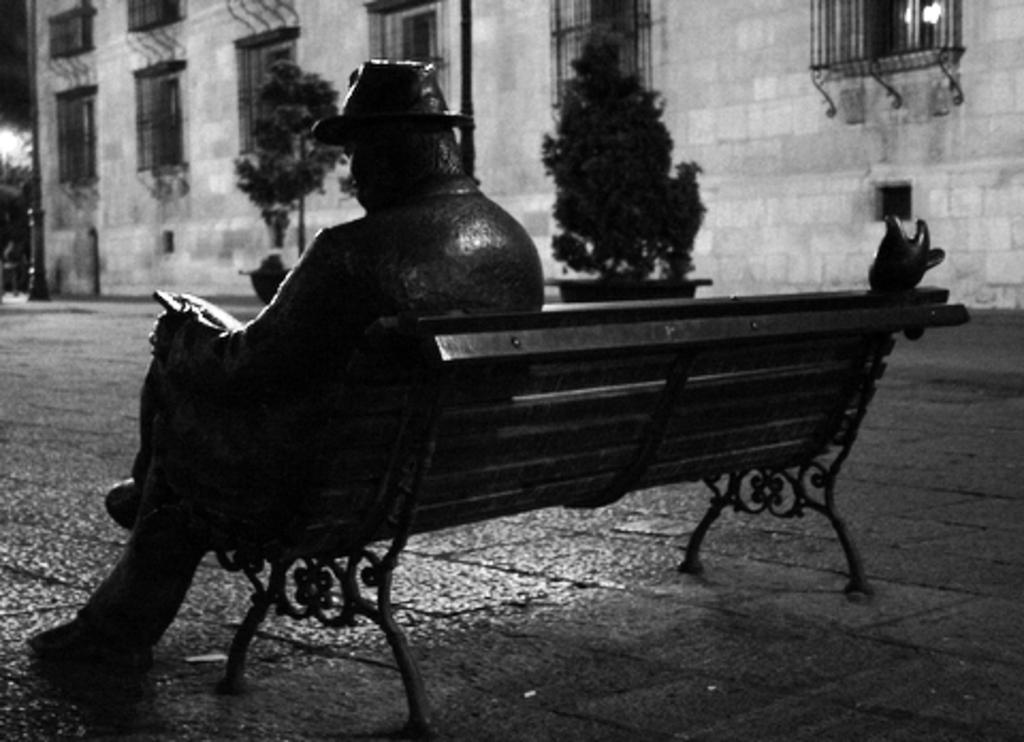What is the main subject of the image? There is a statue of a person sitting on a bench in the image. What can be seen in the background of the image? There is a building in the background of the image. What type of natural elements are visible in the image? There are trees visible in the image. How many bears are holding umbrellas in the image? There are no bears or umbrellas present in the image. 